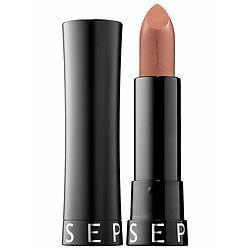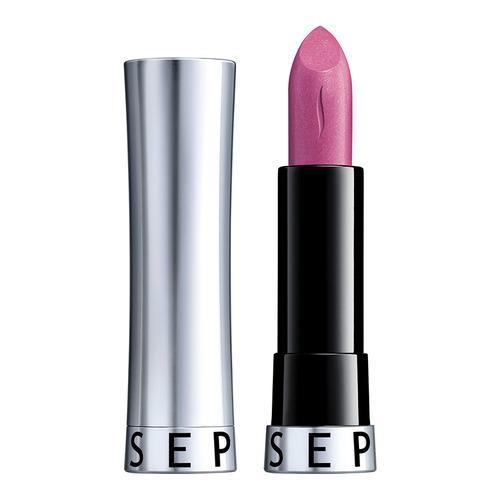The first image is the image on the left, the second image is the image on the right. Evaluate the accuracy of this statement regarding the images: "Each image shows just one standard lipstick next to only its lid.". Is it true? Answer yes or no. Yes. The first image is the image on the left, the second image is the image on the right. Assess this claim about the two images: "One lipstick has a silver casing and the other has a black casing.". Correct or not? Answer yes or no. Yes. 